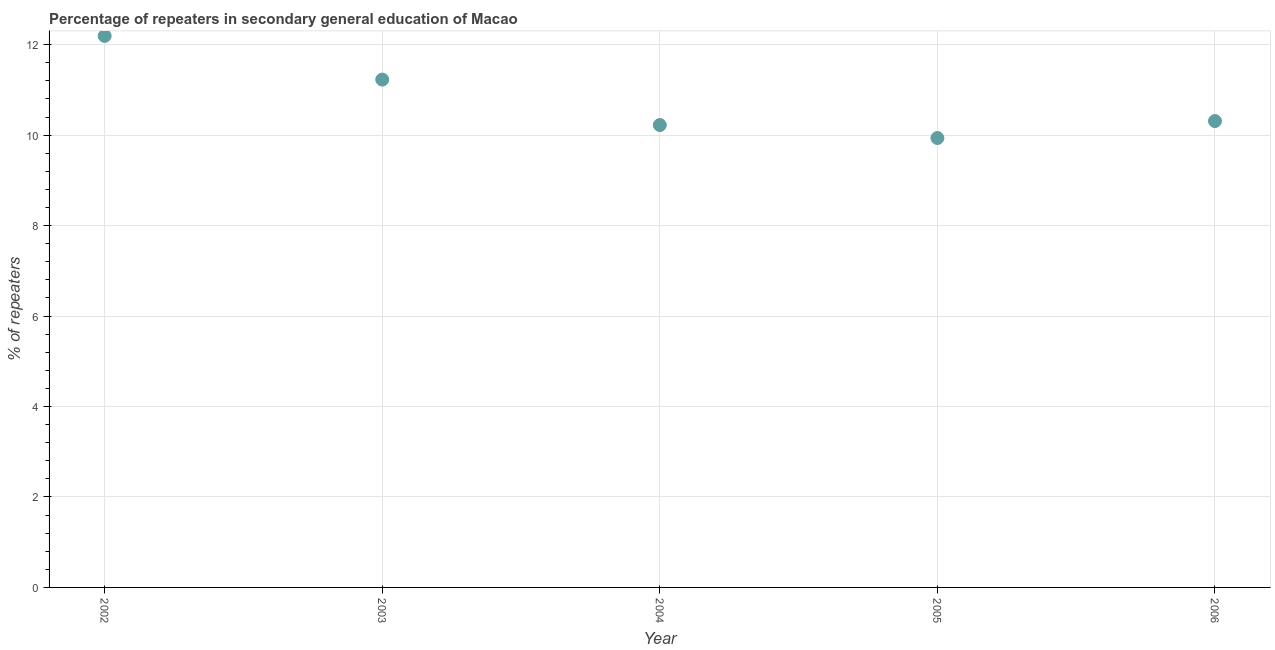What is the percentage of repeaters in 2006?
Provide a short and direct response. 10.31. Across all years, what is the maximum percentage of repeaters?
Keep it short and to the point. 12.19. Across all years, what is the minimum percentage of repeaters?
Make the answer very short. 9.94. What is the sum of the percentage of repeaters?
Provide a short and direct response. 53.89. What is the difference between the percentage of repeaters in 2002 and 2003?
Offer a terse response. 0.97. What is the average percentage of repeaters per year?
Your answer should be very brief. 10.78. What is the median percentage of repeaters?
Your answer should be compact. 10.31. What is the ratio of the percentage of repeaters in 2004 to that in 2005?
Provide a succinct answer. 1.03. Is the percentage of repeaters in 2003 less than that in 2006?
Provide a succinct answer. No. What is the difference between the highest and the second highest percentage of repeaters?
Ensure brevity in your answer.  0.97. Is the sum of the percentage of repeaters in 2002 and 2005 greater than the maximum percentage of repeaters across all years?
Give a very brief answer. Yes. What is the difference between the highest and the lowest percentage of repeaters?
Provide a succinct answer. 2.26. In how many years, is the percentage of repeaters greater than the average percentage of repeaters taken over all years?
Your response must be concise. 2. What is the difference between two consecutive major ticks on the Y-axis?
Make the answer very short. 2. Are the values on the major ticks of Y-axis written in scientific E-notation?
Ensure brevity in your answer.  No. Does the graph contain any zero values?
Keep it short and to the point. No. Does the graph contain grids?
Offer a terse response. Yes. What is the title of the graph?
Offer a very short reply. Percentage of repeaters in secondary general education of Macao. What is the label or title of the Y-axis?
Your response must be concise. % of repeaters. What is the % of repeaters in 2002?
Your answer should be very brief. 12.19. What is the % of repeaters in 2003?
Your response must be concise. 11.23. What is the % of repeaters in 2004?
Your answer should be very brief. 10.22. What is the % of repeaters in 2005?
Your answer should be compact. 9.94. What is the % of repeaters in 2006?
Give a very brief answer. 10.31. What is the difference between the % of repeaters in 2002 and 2003?
Your answer should be compact. 0.97. What is the difference between the % of repeaters in 2002 and 2004?
Make the answer very short. 1.97. What is the difference between the % of repeaters in 2002 and 2005?
Offer a terse response. 2.26. What is the difference between the % of repeaters in 2002 and 2006?
Offer a terse response. 1.88. What is the difference between the % of repeaters in 2003 and 2005?
Keep it short and to the point. 1.29. What is the difference between the % of repeaters in 2003 and 2006?
Provide a short and direct response. 0.92. What is the difference between the % of repeaters in 2004 and 2005?
Offer a terse response. 0.29. What is the difference between the % of repeaters in 2004 and 2006?
Provide a succinct answer. -0.09. What is the difference between the % of repeaters in 2005 and 2006?
Offer a very short reply. -0.37. What is the ratio of the % of repeaters in 2002 to that in 2003?
Offer a very short reply. 1.09. What is the ratio of the % of repeaters in 2002 to that in 2004?
Your answer should be very brief. 1.19. What is the ratio of the % of repeaters in 2002 to that in 2005?
Provide a short and direct response. 1.23. What is the ratio of the % of repeaters in 2002 to that in 2006?
Your answer should be very brief. 1.18. What is the ratio of the % of repeaters in 2003 to that in 2004?
Keep it short and to the point. 1.1. What is the ratio of the % of repeaters in 2003 to that in 2005?
Your answer should be compact. 1.13. What is the ratio of the % of repeaters in 2003 to that in 2006?
Your answer should be very brief. 1.09. What is the ratio of the % of repeaters in 2004 to that in 2006?
Provide a short and direct response. 0.99. What is the ratio of the % of repeaters in 2005 to that in 2006?
Provide a succinct answer. 0.96. 